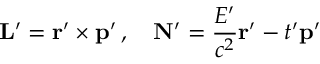Convert formula to latex. <formula><loc_0><loc_0><loc_500><loc_500>L ^ { \prime } = r ^ { \prime } \times p ^ { \prime } \, , \quad N ^ { \prime } = { \frac { E ^ { \prime } } { c ^ { 2 } } } r ^ { \prime } - t ^ { \prime } p ^ { \prime }</formula> 